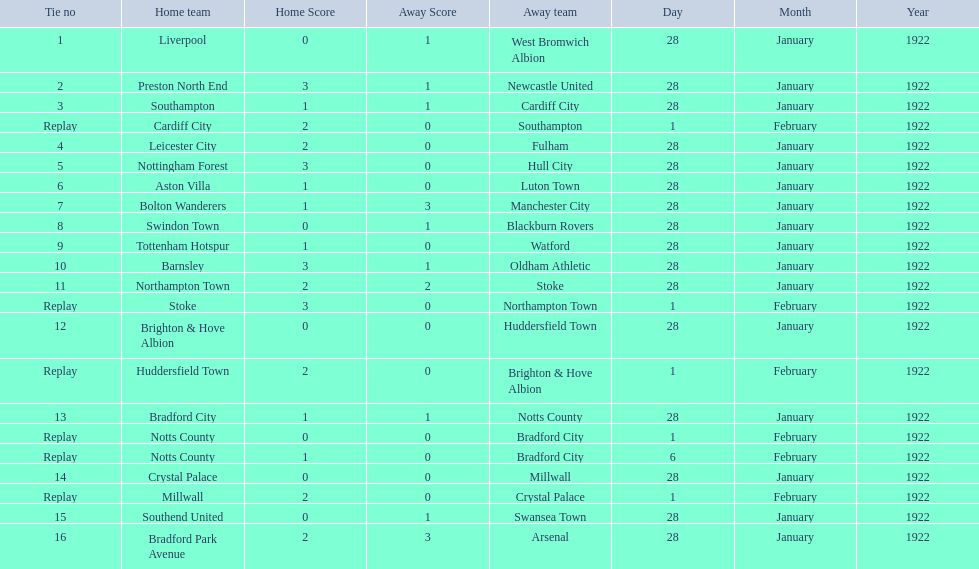Who is the first home team listed as having a score of 3-1? Preston North End. 